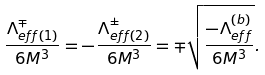<formula> <loc_0><loc_0><loc_500><loc_500>\frac { \Lambda _ { e f f ( 1 ) } ^ { \mp } } { 6 M ^ { 3 } } = - \frac { \Lambda _ { e f f ( 2 ) } ^ { \pm } } { 6 M ^ { 3 } } = \mp \sqrt { \frac { - \Lambda _ { e f f } ^ { ( b ) } } { 6 M ^ { 3 } } } .</formula> 